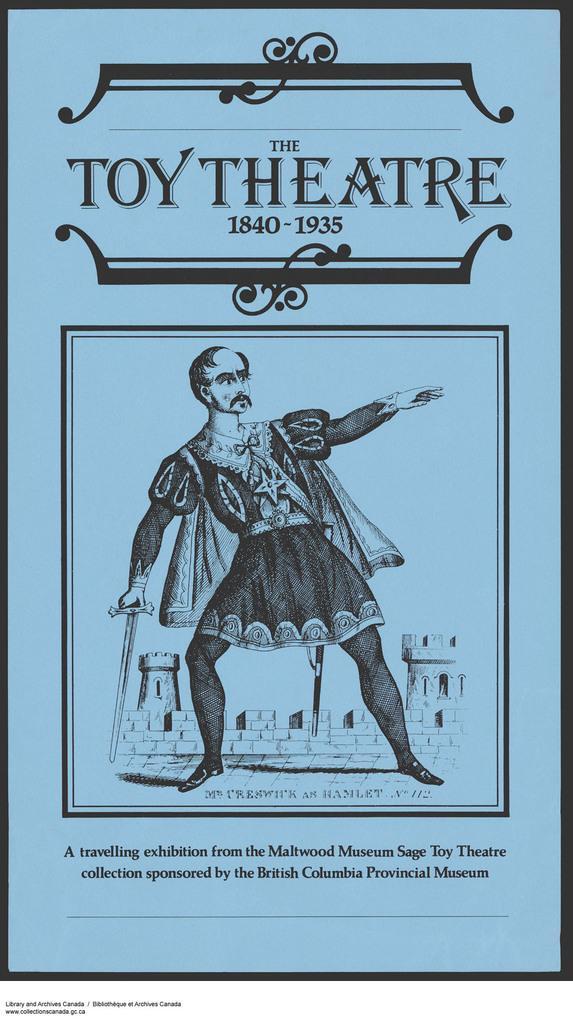Could you give a brief overview of what you see in this image? In this picture we can see a cover page, in the cover page we can find a man. 